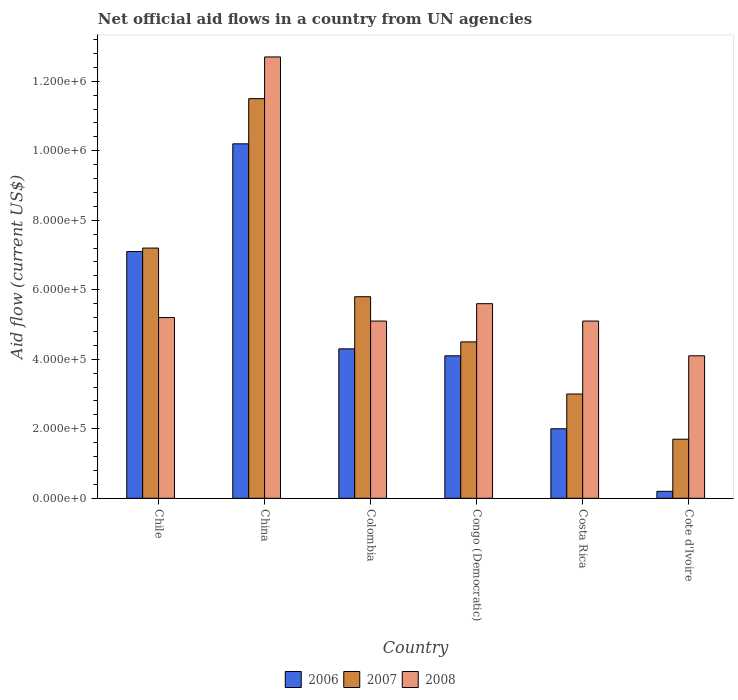How many groups of bars are there?
Provide a succinct answer. 6. Are the number of bars on each tick of the X-axis equal?
Ensure brevity in your answer.  Yes. How many bars are there on the 2nd tick from the left?
Provide a short and direct response. 3. How many bars are there on the 4th tick from the right?
Your response must be concise. 3. In how many cases, is the number of bars for a given country not equal to the number of legend labels?
Your answer should be compact. 0. What is the net official aid flow in 2007 in Colombia?
Your answer should be very brief. 5.80e+05. Across all countries, what is the maximum net official aid flow in 2008?
Your answer should be compact. 1.27e+06. In which country was the net official aid flow in 2006 minimum?
Your answer should be compact. Cote d'Ivoire. What is the total net official aid flow in 2006 in the graph?
Keep it short and to the point. 2.79e+06. What is the difference between the net official aid flow in 2008 in China and that in Congo (Democratic)?
Offer a very short reply. 7.10e+05. What is the difference between the net official aid flow in 2008 in Chile and the net official aid flow in 2006 in Congo (Democratic)?
Your answer should be very brief. 1.10e+05. What is the average net official aid flow in 2006 per country?
Provide a short and direct response. 4.65e+05. What is the difference between the net official aid flow of/in 2006 and net official aid flow of/in 2007 in Colombia?
Your response must be concise. -1.50e+05. What is the ratio of the net official aid flow in 2008 in Chile to that in Congo (Democratic)?
Ensure brevity in your answer.  0.93. Is the net official aid flow in 2006 in Colombia less than that in Cote d'Ivoire?
Give a very brief answer. No. What is the difference between the highest and the second highest net official aid flow in 2007?
Offer a terse response. 4.30e+05. What is the difference between the highest and the lowest net official aid flow in 2007?
Ensure brevity in your answer.  9.80e+05. In how many countries, is the net official aid flow in 2007 greater than the average net official aid flow in 2007 taken over all countries?
Offer a terse response. 3. What does the 1st bar from the left in China represents?
Offer a very short reply. 2006. What does the 2nd bar from the right in Cote d'Ivoire represents?
Your answer should be very brief. 2007. Is it the case that in every country, the sum of the net official aid flow in 2006 and net official aid flow in 2007 is greater than the net official aid flow in 2008?
Give a very brief answer. No. How many bars are there?
Your response must be concise. 18. How many countries are there in the graph?
Your response must be concise. 6. Are the values on the major ticks of Y-axis written in scientific E-notation?
Make the answer very short. Yes. Does the graph contain grids?
Offer a very short reply. No. How many legend labels are there?
Offer a terse response. 3. How are the legend labels stacked?
Your answer should be very brief. Horizontal. What is the title of the graph?
Make the answer very short. Net official aid flows in a country from UN agencies. What is the label or title of the X-axis?
Your answer should be compact. Country. What is the Aid flow (current US$) of 2006 in Chile?
Provide a short and direct response. 7.10e+05. What is the Aid flow (current US$) of 2007 in Chile?
Provide a succinct answer. 7.20e+05. What is the Aid flow (current US$) of 2008 in Chile?
Offer a very short reply. 5.20e+05. What is the Aid flow (current US$) of 2006 in China?
Keep it short and to the point. 1.02e+06. What is the Aid flow (current US$) in 2007 in China?
Offer a very short reply. 1.15e+06. What is the Aid flow (current US$) in 2008 in China?
Offer a terse response. 1.27e+06. What is the Aid flow (current US$) of 2006 in Colombia?
Your response must be concise. 4.30e+05. What is the Aid flow (current US$) in 2007 in Colombia?
Give a very brief answer. 5.80e+05. What is the Aid flow (current US$) of 2008 in Colombia?
Your answer should be compact. 5.10e+05. What is the Aid flow (current US$) of 2007 in Congo (Democratic)?
Your answer should be very brief. 4.50e+05. What is the Aid flow (current US$) in 2008 in Congo (Democratic)?
Your response must be concise. 5.60e+05. What is the Aid flow (current US$) in 2006 in Costa Rica?
Ensure brevity in your answer.  2.00e+05. What is the Aid flow (current US$) in 2008 in Costa Rica?
Offer a very short reply. 5.10e+05. What is the Aid flow (current US$) of 2008 in Cote d'Ivoire?
Give a very brief answer. 4.10e+05. Across all countries, what is the maximum Aid flow (current US$) of 2006?
Offer a very short reply. 1.02e+06. Across all countries, what is the maximum Aid flow (current US$) of 2007?
Make the answer very short. 1.15e+06. Across all countries, what is the maximum Aid flow (current US$) of 2008?
Offer a very short reply. 1.27e+06. Across all countries, what is the minimum Aid flow (current US$) of 2006?
Provide a succinct answer. 2.00e+04. What is the total Aid flow (current US$) in 2006 in the graph?
Provide a succinct answer. 2.79e+06. What is the total Aid flow (current US$) in 2007 in the graph?
Offer a very short reply. 3.37e+06. What is the total Aid flow (current US$) in 2008 in the graph?
Your answer should be very brief. 3.78e+06. What is the difference between the Aid flow (current US$) of 2006 in Chile and that in China?
Offer a very short reply. -3.10e+05. What is the difference between the Aid flow (current US$) in 2007 in Chile and that in China?
Ensure brevity in your answer.  -4.30e+05. What is the difference between the Aid flow (current US$) in 2008 in Chile and that in China?
Offer a terse response. -7.50e+05. What is the difference between the Aid flow (current US$) in 2007 in Chile and that in Colombia?
Offer a very short reply. 1.40e+05. What is the difference between the Aid flow (current US$) in 2007 in Chile and that in Congo (Democratic)?
Ensure brevity in your answer.  2.70e+05. What is the difference between the Aid flow (current US$) in 2006 in Chile and that in Costa Rica?
Provide a succinct answer. 5.10e+05. What is the difference between the Aid flow (current US$) of 2007 in Chile and that in Costa Rica?
Make the answer very short. 4.20e+05. What is the difference between the Aid flow (current US$) of 2006 in Chile and that in Cote d'Ivoire?
Make the answer very short. 6.90e+05. What is the difference between the Aid flow (current US$) in 2008 in Chile and that in Cote d'Ivoire?
Offer a terse response. 1.10e+05. What is the difference between the Aid flow (current US$) of 2006 in China and that in Colombia?
Your answer should be compact. 5.90e+05. What is the difference between the Aid flow (current US$) in 2007 in China and that in Colombia?
Keep it short and to the point. 5.70e+05. What is the difference between the Aid flow (current US$) in 2008 in China and that in Colombia?
Your answer should be compact. 7.60e+05. What is the difference between the Aid flow (current US$) in 2006 in China and that in Congo (Democratic)?
Provide a succinct answer. 6.10e+05. What is the difference between the Aid flow (current US$) of 2007 in China and that in Congo (Democratic)?
Keep it short and to the point. 7.00e+05. What is the difference between the Aid flow (current US$) of 2008 in China and that in Congo (Democratic)?
Provide a succinct answer. 7.10e+05. What is the difference between the Aid flow (current US$) of 2006 in China and that in Costa Rica?
Make the answer very short. 8.20e+05. What is the difference between the Aid flow (current US$) of 2007 in China and that in Costa Rica?
Keep it short and to the point. 8.50e+05. What is the difference between the Aid flow (current US$) in 2008 in China and that in Costa Rica?
Keep it short and to the point. 7.60e+05. What is the difference between the Aid flow (current US$) of 2007 in China and that in Cote d'Ivoire?
Your answer should be very brief. 9.80e+05. What is the difference between the Aid flow (current US$) of 2008 in China and that in Cote d'Ivoire?
Provide a short and direct response. 8.60e+05. What is the difference between the Aid flow (current US$) in 2006 in Colombia and that in Congo (Democratic)?
Provide a short and direct response. 2.00e+04. What is the difference between the Aid flow (current US$) of 2006 in Colombia and that in Costa Rica?
Provide a succinct answer. 2.30e+05. What is the difference between the Aid flow (current US$) in 2007 in Colombia and that in Costa Rica?
Your response must be concise. 2.80e+05. What is the difference between the Aid flow (current US$) in 2008 in Colombia and that in Costa Rica?
Provide a succinct answer. 0. What is the difference between the Aid flow (current US$) of 2006 in Colombia and that in Cote d'Ivoire?
Your answer should be very brief. 4.10e+05. What is the difference between the Aid flow (current US$) in 2007 in Colombia and that in Cote d'Ivoire?
Provide a succinct answer. 4.10e+05. What is the difference between the Aid flow (current US$) of 2008 in Colombia and that in Cote d'Ivoire?
Your response must be concise. 1.00e+05. What is the difference between the Aid flow (current US$) in 2008 in Congo (Democratic) and that in Costa Rica?
Offer a terse response. 5.00e+04. What is the difference between the Aid flow (current US$) of 2006 in Congo (Democratic) and that in Cote d'Ivoire?
Your response must be concise. 3.90e+05. What is the difference between the Aid flow (current US$) of 2008 in Costa Rica and that in Cote d'Ivoire?
Your answer should be very brief. 1.00e+05. What is the difference between the Aid flow (current US$) of 2006 in Chile and the Aid flow (current US$) of 2007 in China?
Offer a very short reply. -4.40e+05. What is the difference between the Aid flow (current US$) in 2006 in Chile and the Aid flow (current US$) in 2008 in China?
Keep it short and to the point. -5.60e+05. What is the difference between the Aid flow (current US$) of 2007 in Chile and the Aid flow (current US$) of 2008 in China?
Ensure brevity in your answer.  -5.50e+05. What is the difference between the Aid flow (current US$) in 2007 in Chile and the Aid flow (current US$) in 2008 in Colombia?
Offer a terse response. 2.10e+05. What is the difference between the Aid flow (current US$) of 2007 in Chile and the Aid flow (current US$) of 2008 in Congo (Democratic)?
Your answer should be very brief. 1.60e+05. What is the difference between the Aid flow (current US$) of 2007 in Chile and the Aid flow (current US$) of 2008 in Costa Rica?
Provide a succinct answer. 2.10e+05. What is the difference between the Aid flow (current US$) of 2006 in Chile and the Aid flow (current US$) of 2007 in Cote d'Ivoire?
Keep it short and to the point. 5.40e+05. What is the difference between the Aid flow (current US$) in 2006 in Chile and the Aid flow (current US$) in 2008 in Cote d'Ivoire?
Your answer should be compact. 3.00e+05. What is the difference between the Aid flow (current US$) of 2006 in China and the Aid flow (current US$) of 2007 in Colombia?
Provide a short and direct response. 4.40e+05. What is the difference between the Aid flow (current US$) in 2006 in China and the Aid flow (current US$) in 2008 in Colombia?
Give a very brief answer. 5.10e+05. What is the difference between the Aid flow (current US$) in 2007 in China and the Aid flow (current US$) in 2008 in Colombia?
Keep it short and to the point. 6.40e+05. What is the difference between the Aid flow (current US$) of 2006 in China and the Aid flow (current US$) of 2007 in Congo (Democratic)?
Ensure brevity in your answer.  5.70e+05. What is the difference between the Aid flow (current US$) of 2007 in China and the Aid flow (current US$) of 2008 in Congo (Democratic)?
Make the answer very short. 5.90e+05. What is the difference between the Aid flow (current US$) in 2006 in China and the Aid flow (current US$) in 2007 in Costa Rica?
Make the answer very short. 7.20e+05. What is the difference between the Aid flow (current US$) of 2006 in China and the Aid flow (current US$) of 2008 in Costa Rica?
Make the answer very short. 5.10e+05. What is the difference between the Aid flow (current US$) in 2007 in China and the Aid flow (current US$) in 2008 in Costa Rica?
Provide a succinct answer. 6.40e+05. What is the difference between the Aid flow (current US$) in 2006 in China and the Aid flow (current US$) in 2007 in Cote d'Ivoire?
Offer a very short reply. 8.50e+05. What is the difference between the Aid flow (current US$) in 2006 in China and the Aid flow (current US$) in 2008 in Cote d'Ivoire?
Your answer should be very brief. 6.10e+05. What is the difference between the Aid flow (current US$) of 2007 in China and the Aid flow (current US$) of 2008 in Cote d'Ivoire?
Your response must be concise. 7.40e+05. What is the difference between the Aid flow (current US$) in 2007 in Colombia and the Aid flow (current US$) in 2008 in Cote d'Ivoire?
Make the answer very short. 1.70e+05. What is the difference between the Aid flow (current US$) in 2006 in Congo (Democratic) and the Aid flow (current US$) in 2007 in Costa Rica?
Your response must be concise. 1.10e+05. What is the difference between the Aid flow (current US$) in 2006 in Congo (Democratic) and the Aid flow (current US$) in 2008 in Costa Rica?
Make the answer very short. -1.00e+05. What is the difference between the Aid flow (current US$) of 2007 in Congo (Democratic) and the Aid flow (current US$) of 2008 in Costa Rica?
Your response must be concise. -6.00e+04. What is the difference between the Aid flow (current US$) in 2006 in Congo (Democratic) and the Aid flow (current US$) in 2007 in Cote d'Ivoire?
Your response must be concise. 2.40e+05. What is the difference between the Aid flow (current US$) in 2006 in Congo (Democratic) and the Aid flow (current US$) in 2008 in Cote d'Ivoire?
Your response must be concise. 0. What is the difference between the Aid flow (current US$) in 2007 in Congo (Democratic) and the Aid flow (current US$) in 2008 in Cote d'Ivoire?
Your answer should be very brief. 4.00e+04. What is the average Aid flow (current US$) of 2006 per country?
Make the answer very short. 4.65e+05. What is the average Aid flow (current US$) of 2007 per country?
Provide a succinct answer. 5.62e+05. What is the average Aid flow (current US$) in 2008 per country?
Keep it short and to the point. 6.30e+05. What is the difference between the Aid flow (current US$) in 2006 and Aid flow (current US$) in 2007 in Chile?
Your response must be concise. -10000. What is the difference between the Aid flow (current US$) in 2006 and Aid flow (current US$) in 2008 in China?
Offer a very short reply. -2.50e+05. What is the difference between the Aid flow (current US$) in 2006 and Aid flow (current US$) in 2007 in Colombia?
Your answer should be compact. -1.50e+05. What is the difference between the Aid flow (current US$) of 2006 and Aid flow (current US$) of 2008 in Colombia?
Give a very brief answer. -8.00e+04. What is the difference between the Aid flow (current US$) in 2006 and Aid flow (current US$) in 2007 in Congo (Democratic)?
Keep it short and to the point. -4.00e+04. What is the difference between the Aid flow (current US$) in 2006 and Aid flow (current US$) in 2008 in Congo (Democratic)?
Offer a terse response. -1.50e+05. What is the difference between the Aid flow (current US$) of 2007 and Aid flow (current US$) of 2008 in Congo (Democratic)?
Ensure brevity in your answer.  -1.10e+05. What is the difference between the Aid flow (current US$) in 2006 and Aid flow (current US$) in 2007 in Costa Rica?
Ensure brevity in your answer.  -1.00e+05. What is the difference between the Aid flow (current US$) in 2006 and Aid flow (current US$) in 2008 in Costa Rica?
Your answer should be very brief. -3.10e+05. What is the difference between the Aid flow (current US$) in 2006 and Aid flow (current US$) in 2008 in Cote d'Ivoire?
Your response must be concise. -3.90e+05. What is the ratio of the Aid flow (current US$) in 2006 in Chile to that in China?
Your response must be concise. 0.7. What is the ratio of the Aid flow (current US$) of 2007 in Chile to that in China?
Ensure brevity in your answer.  0.63. What is the ratio of the Aid flow (current US$) in 2008 in Chile to that in China?
Make the answer very short. 0.41. What is the ratio of the Aid flow (current US$) in 2006 in Chile to that in Colombia?
Give a very brief answer. 1.65. What is the ratio of the Aid flow (current US$) in 2007 in Chile to that in Colombia?
Offer a terse response. 1.24. What is the ratio of the Aid flow (current US$) of 2008 in Chile to that in Colombia?
Give a very brief answer. 1.02. What is the ratio of the Aid flow (current US$) of 2006 in Chile to that in Congo (Democratic)?
Make the answer very short. 1.73. What is the ratio of the Aid flow (current US$) of 2007 in Chile to that in Congo (Democratic)?
Keep it short and to the point. 1.6. What is the ratio of the Aid flow (current US$) in 2006 in Chile to that in Costa Rica?
Keep it short and to the point. 3.55. What is the ratio of the Aid flow (current US$) of 2007 in Chile to that in Costa Rica?
Offer a very short reply. 2.4. What is the ratio of the Aid flow (current US$) in 2008 in Chile to that in Costa Rica?
Your answer should be very brief. 1.02. What is the ratio of the Aid flow (current US$) of 2006 in Chile to that in Cote d'Ivoire?
Your response must be concise. 35.5. What is the ratio of the Aid flow (current US$) in 2007 in Chile to that in Cote d'Ivoire?
Offer a terse response. 4.24. What is the ratio of the Aid flow (current US$) in 2008 in Chile to that in Cote d'Ivoire?
Give a very brief answer. 1.27. What is the ratio of the Aid flow (current US$) of 2006 in China to that in Colombia?
Make the answer very short. 2.37. What is the ratio of the Aid flow (current US$) of 2007 in China to that in Colombia?
Your response must be concise. 1.98. What is the ratio of the Aid flow (current US$) in 2008 in China to that in Colombia?
Your response must be concise. 2.49. What is the ratio of the Aid flow (current US$) of 2006 in China to that in Congo (Democratic)?
Offer a very short reply. 2.49. What is the ratio of the Aid flow (current US$) in 2007 in China to that in Congo (Democratic)?
Offer a terse response. 2.56. What is the ratio of the Aid flow (current US$) in 2008 in China to that in Congo (Democratic)?
Offer a terse response. 2.27. What is the ratio of the Aid flow (current US$) in 2007 in China to that in Costa Rica?
Your answer should be very brief. 3.83. What is the ratio of the Aid flow (current US$) of 2008 in China to that in Costa Rica?
Your answer should be compact. 2.49. What is the ratio of the Aid flow (current US$) of 2007 in China to that in Cote d'Ivoire?
Your response must be concise. 6.76. What is the ratio of the Aid flow (current US$) in 2008 in China to that in Cote d'Ivoire?
Provide a succinct answer. 3.1. What is the ratio of the Aid flow (current US$) in 2006 in Colombia to that in Congo (Democratic)?
Provide a short and direct response. 1.05. What is the ratio of the Aid flow (current US$) of 2007 in Colombia to that in Congo (Democratic)?
Your answer should be very brief. 1.29. What is the ratio of the Aid flow (current US$) in 2008 in Colombia to that in Congo (Democratic)?
Your response must be concise. 0.91. What is the ratio of the Aid flow (current US$) in 2006 in Colombia to that in Costa Rica?
Provide a short and direct response. 2.15. What is the ratio of the Aid flow (current US$) in 2007 in Colombia to that in Costa Rica?
Your response must be concise. 1.93. What is the ratio of the Aid flow (current US$) of 2007 in Colombia to that in Cote d'Ivoire?
Make the answer very short. 3.41. What is the ratio of the Aid flow (current US$) of 2008 in Colombia to that in Cote d'Ivoire?
Offer a very short reply. 1.24. What is the ratio of the Aid flow (current US$) of 2006 in Congo (Democratic) to that in Costa Rica?
Make the answer very short. 2.05. What is the ratio of the Aid flow (current US$) in 2007 in Congo (Democratic) to that in Costa Rica?
Your answer should be compact. 1.5. What is the ratio of the Aid flow (current US$) of 2008 in Congo (Democratic) to that in Costa Rica?
Offer a very short reply. 1.1. What is the ratio of the Aid flow (current US$) in 2007 in Congo (Democratic) to that in Cote d'Ivoire?
Your response must be concise. 2.65. What is the ratio of the Aid flow (current US$) of 2008 in Congo (Democratic) to that in Cote d'Ivoire?
Your answer should be very brief. 1.37. What is the ratio of the Aid flow (current US$) of 2006 in Costa Rica to that in Cote d'Ivoire?
Offer a terse response. 10. What is the ratio of the Aid flow (current US$) of 2007 in Costa Rica to that in Cote d'Ivoire?
Offer a terse response. 1.76. What is the ratio of the Aid flow (current US$) of 2008 in Costa Rica to that in Cote d'Ivoire?
Your answer should be compact. 1.24. What is the difference between the highest and the second highest Aid flow (current US$) in 2007?
Provide a short and direct response. 4.30e+05. What is the difference between the highest and the second highest Aid flow (current US$) in 2008?
Provide a succinct answer. 7.10e+05. What is the difference between the highest and the lowest Aid flow (current US$) of 2006?
Your answer should be very brief. 1.00e+06. What is the difference between the highest and the lowest Aid flow (current US$) of 2007?
Keep it short and to the point. 9.80e+05. What is the difference between the highest and the lowest Aid flow (current US$) of 2008?
Offer a very short reply. 8.60e+05. 